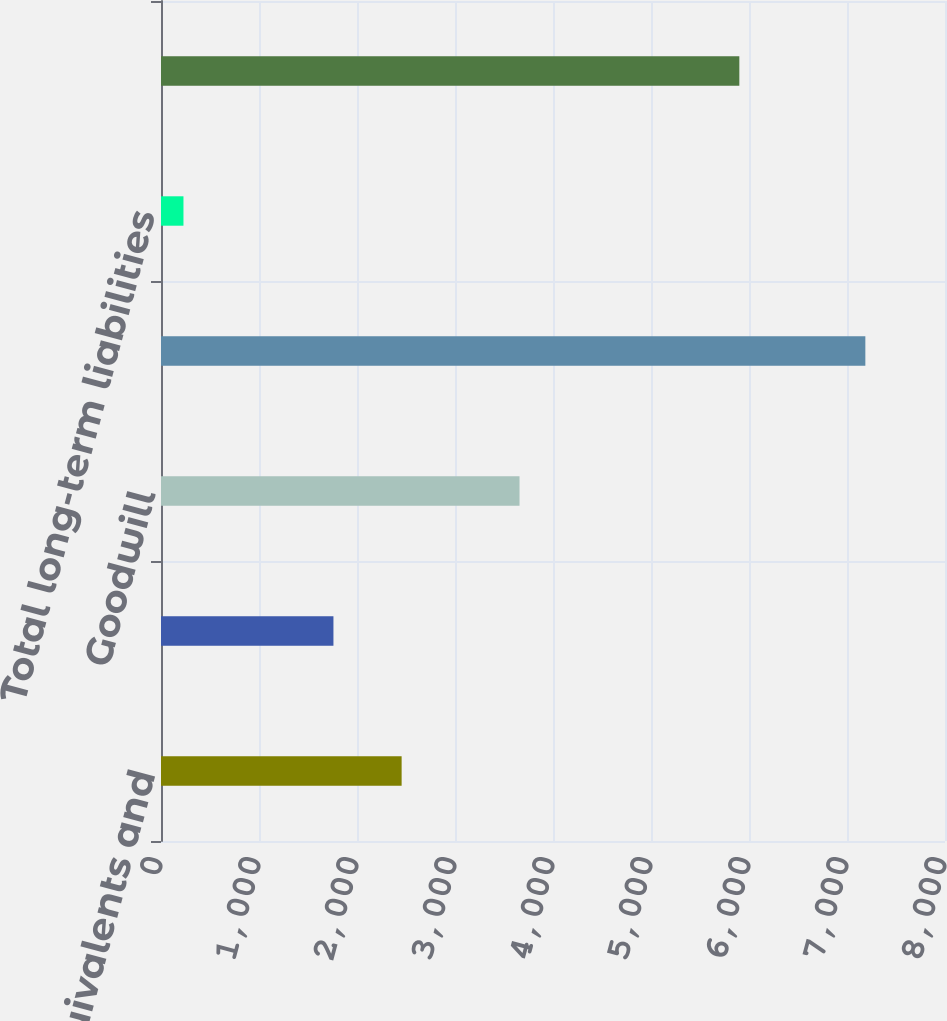Convert chart. <chart><loc_0><loc_0><loc_500><loc_500><bar_chart><fcel>Cash cash equivalents and<fcel>Working capital<fcel>Goodwill<fcel>Total assets<fcel>Total long-term liabilities<fcel>Total Juniper Networks<nl><fcel>2455.4<fcel>1759.6<fcel>3658.6<fcel>7187.3<fcel>229.3<fcel>5901.4<nl></chart> 